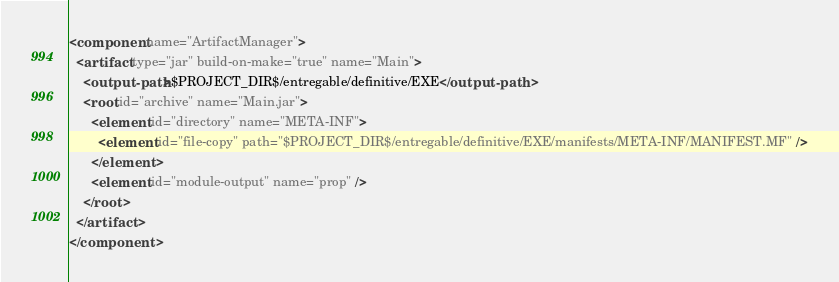<code> <loc_0><loc_0><loc_500><loc_500><_XML_><component name="ArtifactManager">
  <artifact type="jar" build-on-make="true" name="Main">
    <output-path>$PROJECT_DIR$/entregable/definitive/EXE</output-path>
    <root id="archive" name="Main.jar">
      <element id="directory" name="META-INF">
        <element id="file-copy" path="$PROJECT_DIR$/entregable/definitive/EXE/manifests/META-INF/MANIFEST.MF" />
      </element>
      <element id="module-output" name="prop" />
    </root>
  </artifact>
</component></code> 